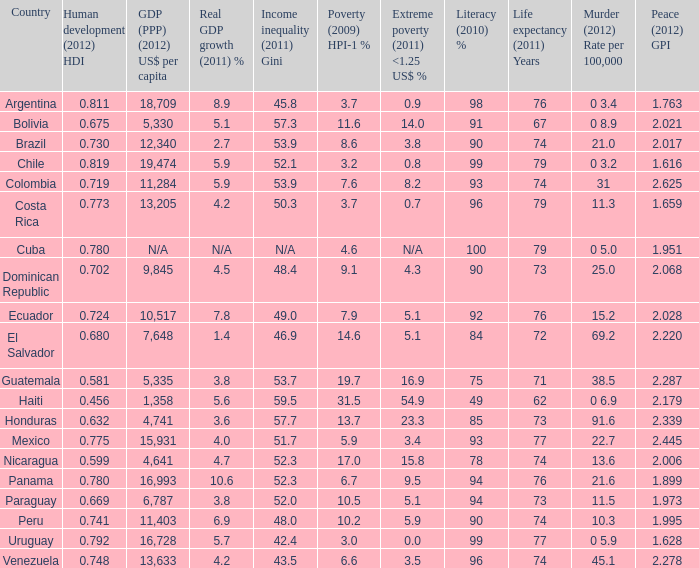What is the sum of poverty (2009) HPI-1 % when the GDP (PPP) (2012) US$ per capita of 11,284? 1.0. 